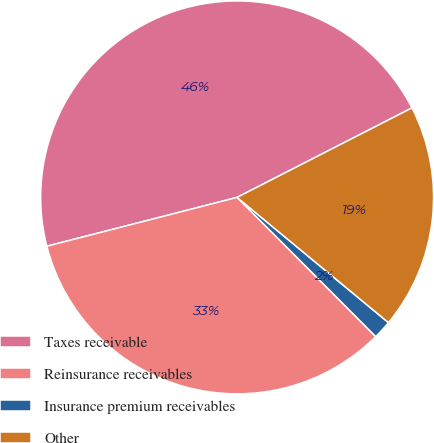<chart> <loc_0><loc_0><loc_500><loc_500><pie_chart><fcel>Taxes receivable<fcel>Reinsurance receivables<fcel>Insurance premium receivables<fcel>Other<nl><fcel>46.47%<fcel>33.47%<fcel>1.53%<fcel>18.53%<nl></chart> 